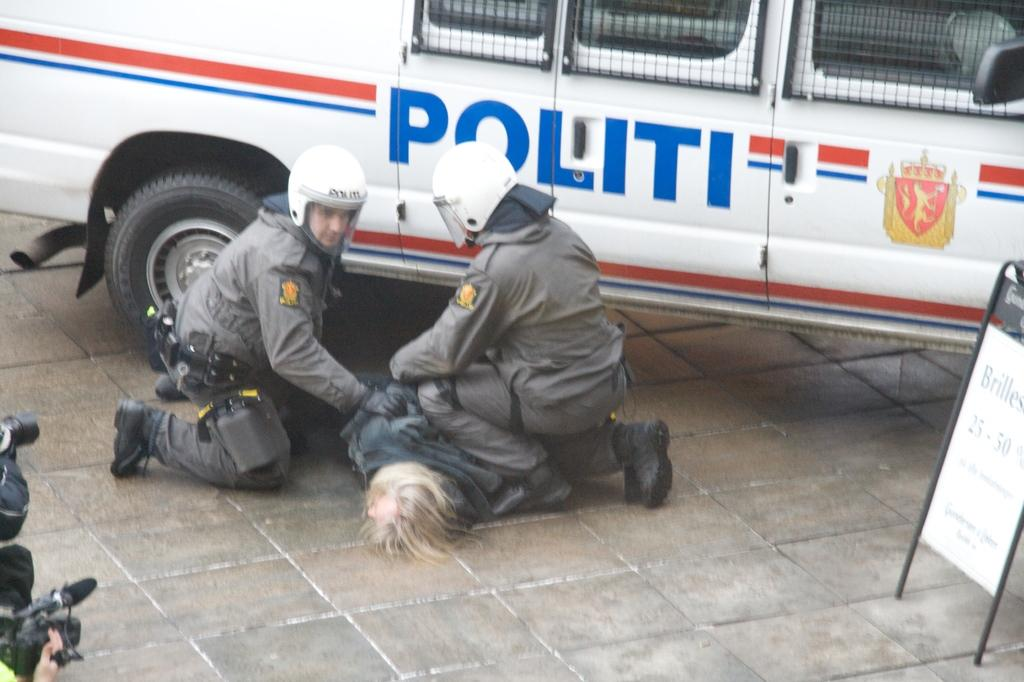How many people are in the image? There are three men in the image. Where are the men located? The men are on the land. What can be seen on the right side of the image? There is a board on the right side of the image. What is visible in the background of the image? There is a vehicle visible in the background of the image. What type of parcel is being delivered by the men in the image? There is no parcel visible in the image, and the men are not shown delivering anything. Can you tell me how many stories the building has in the image? There is no building present in the image; it features three men on the land with a board and a vehicle in the background. 